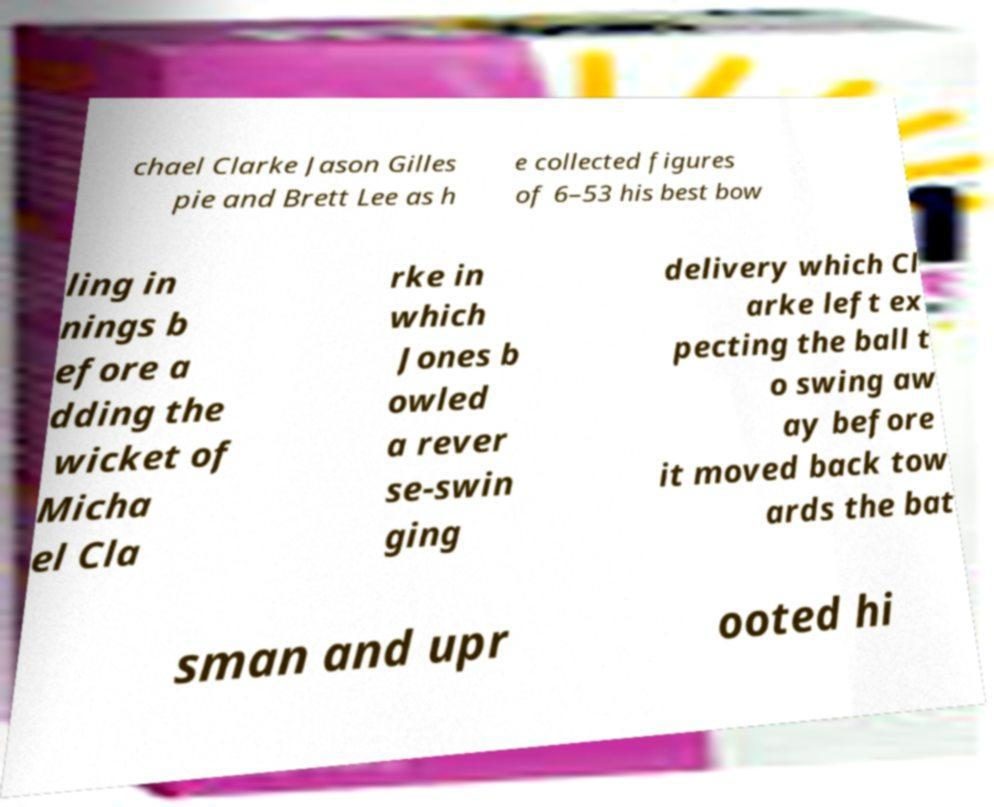There's text embedded in this image that I need extracted. Can you transcribe it verbatim? chael Clarke Jason Gilles pie and Brett Lee as h e collected figures of 6–53 his best bow ling in nings b efore a dding the wicket of Micha el Cla rke in which Jones b owled a rever se-swin ging delivery which Cl arke left ex pecting the ball t o swing aw ay before it moved back tow ards the bat sman and upr ooted hi 